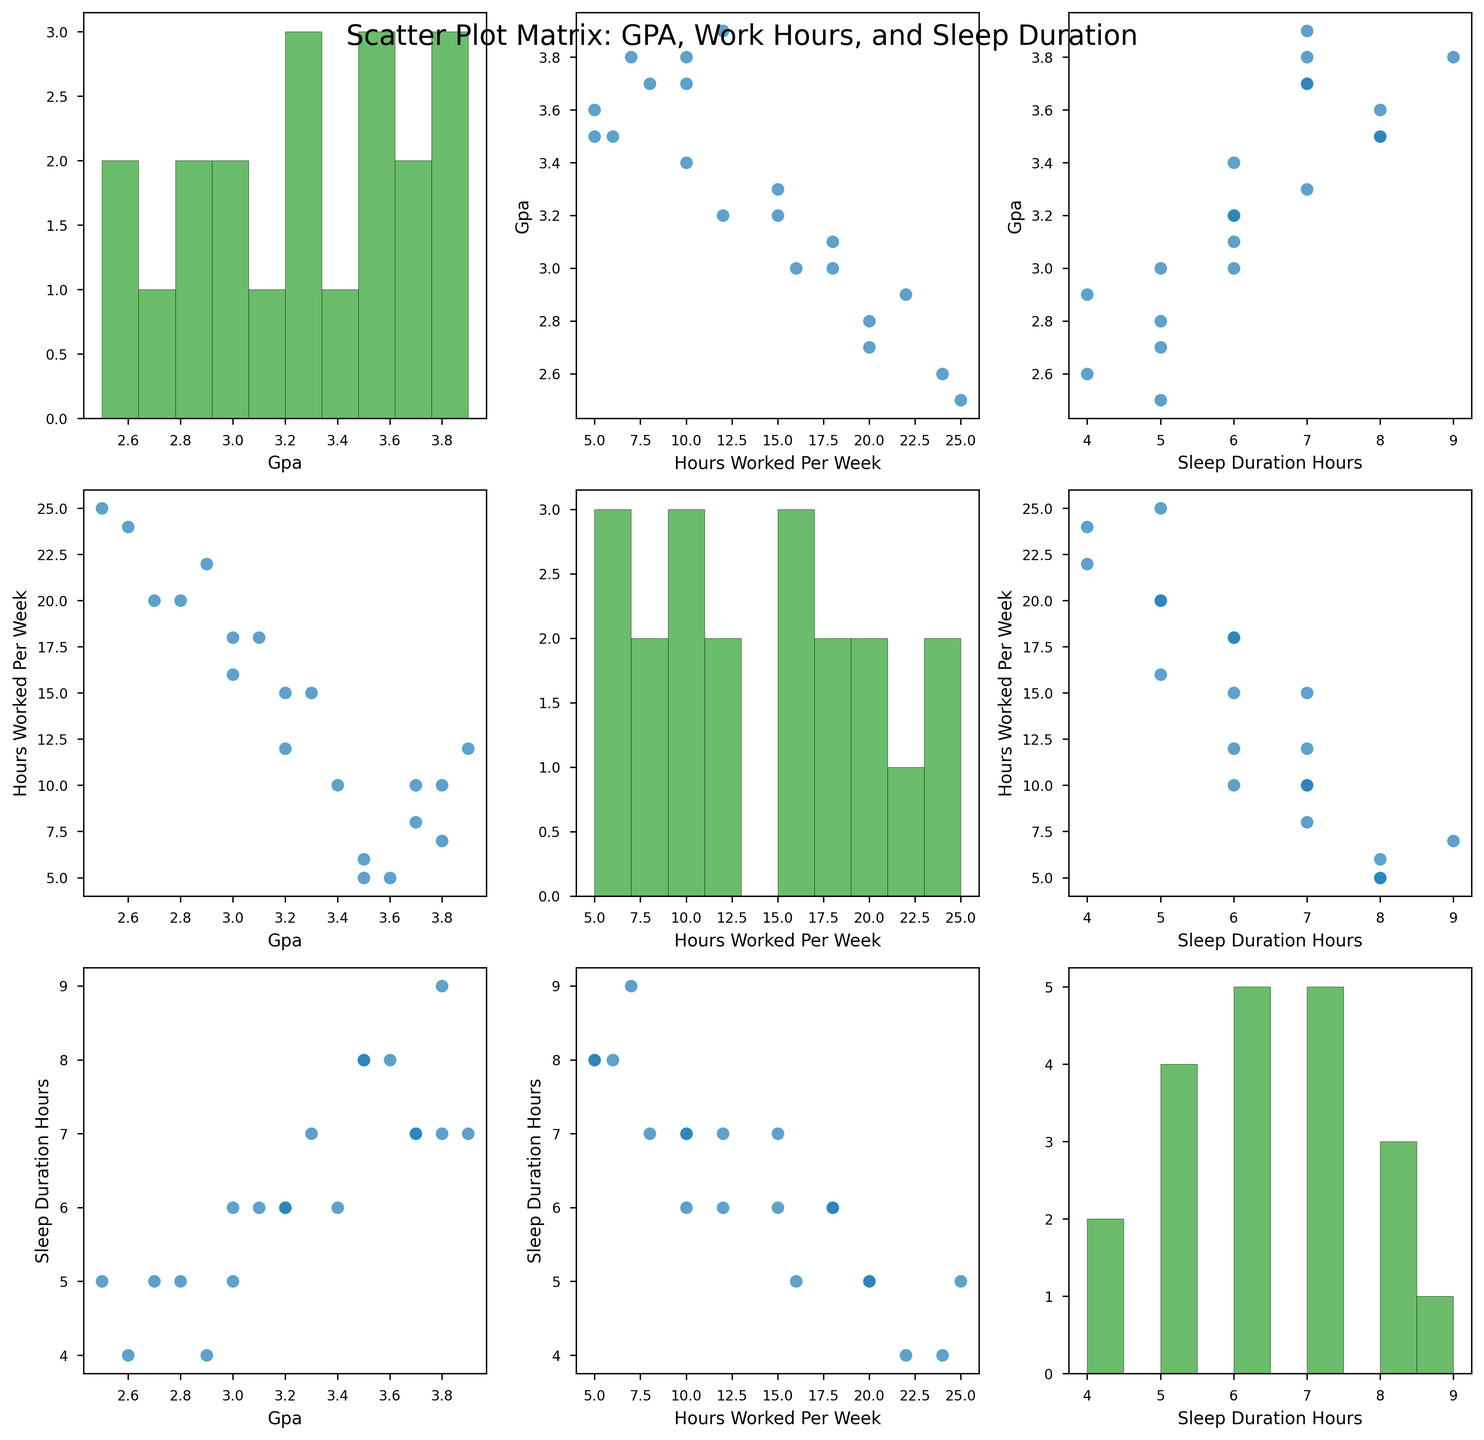What's the title of the figure? The title is placed at the top of the figure and it reads "Scatter Plot Matrix: GPA, Work Hours, and Sleep Duration".
Answer: Scatter Plot Matrix: GPA, Work Hours, and Sleep Duration What is shown along the diagonal of the SPLOM? Along the diagonal of the SPLOM, histograms are shown for each of the three variables: GPA, hours worked per week, and sleep duration.
Answer: Histograms How many variables are plotted in the scatter plot matrix? The scatter plot matrix has three variables: GPA, hours worked per week, and sleep duration.
Answer: Three Is there an observable trend between sleep duration and GPA among the students? By examining the scatter plot between sleep duration and GPA, there seems to be a positive trend where students with more sleep tend to have higher GPAs.
Answer: Positive trend Which variable has the widest distribution in its histogram? The histogram for hours worked per week shows the widest distribution compared to the histograms for GPA and sleep duration.
Answer: Hours worked per week Do more students have a GPA above or below 3.0? By looking at the histogram for GPA, it is apparent that more students have a GPA above 3.0.
Answer: Above 3.0 What can be inferred about the relationship between hours worked per week and sleep duration? In the scatter plot comparing hours worked per week and sleep duration, there is a negative trend indicating that students who work more hours per week tend to have less sleep.
Answer: Negative trend Is there any student who works more than 20 hours per week and also gets 6 or more hours of sleep? By examining the scatter plot of hours worked per week against sleep duration, no data points are in the region where hours worked are more than 20 and sleep duration is 6 or more hours.
Answer: No Which pair of variables seem to have the strongest negative correlation? The scatter plot between hours worked per week and sleep duration shows the strongest negative correlation among the variable pairs.
Answer: Hours worked per week vs. Sleep duration What can you deduce about students who sleep 5 hours or less? From the scatter plots, students who sleep 5 hours or less tend to have lower GPAs and work more hours per week.
Answer: Lower GPAs and work more hours 